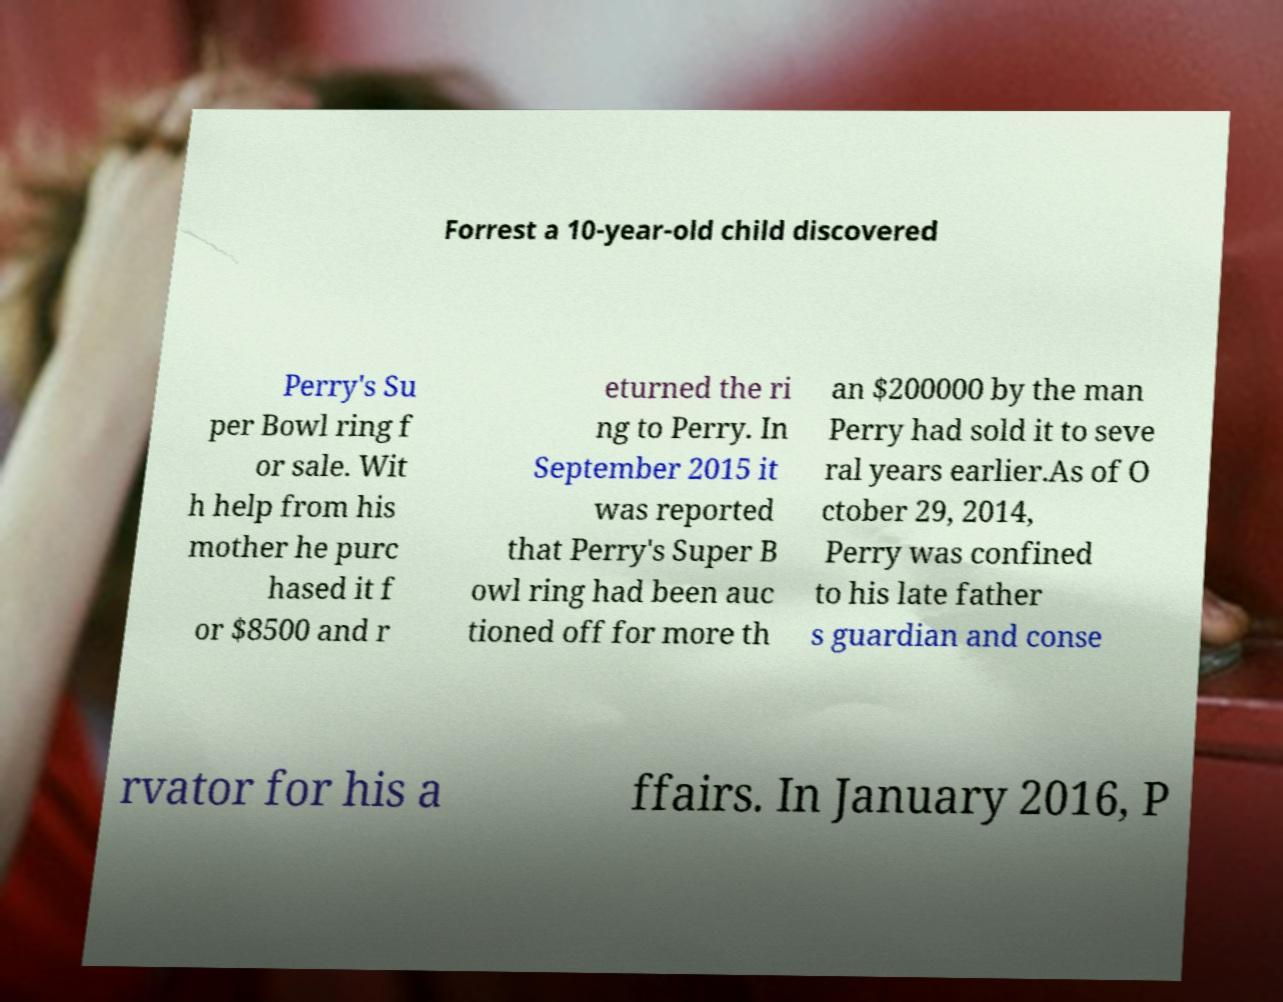For documentation purposes, I need the text within this image transcribed. Could you provide that? Forrest a 10-year-old child discovered Perry's Su per Bowl ring f or sale. Wit h help from his mother he purc hased it f or $8500 and r eturned the ri ng to Perry. In September 2015 it was reported that Perry's Super B owl ring had been auc tioned off for more th an $200000 by the man Perry had sold it to seve ral years earlier.As of O ctober 29, 2014, Perry was confined to his late father s guardian and conse rvator for his a ffairs. In January 2016, P 